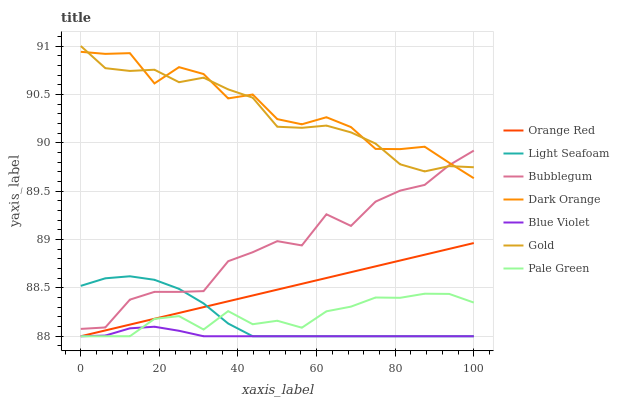Does Gold have the minimum area under the curve?
Answer yes or no. No. Does Gold have the maximum area under the curve?
Answer yes or no. No. Is Gold the smoothest?
Answer yes or no. No. Is Gold the roughest?
Answer yes or no. No. Does Bubblegum have the lowest value?
Answer yes or no. No. Does Bubblegum have the highest value?
Answer yes or no. No. Is Pale Green less than Bubblegum?
Answer yes or no. Yes. Is Bubblegum greater than Blue Violet?
Answer yes or no. Yes. Does Pale Green intersect Bubblegum?
Answer yes or no. No. 